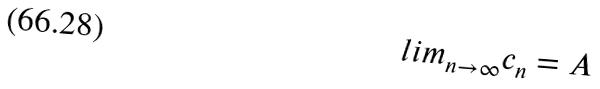<formula> <loc_0><loc_0><loc_500><loc_500>l i m _ { n \rightarrow \infty } c _ { n } = A</formula> 